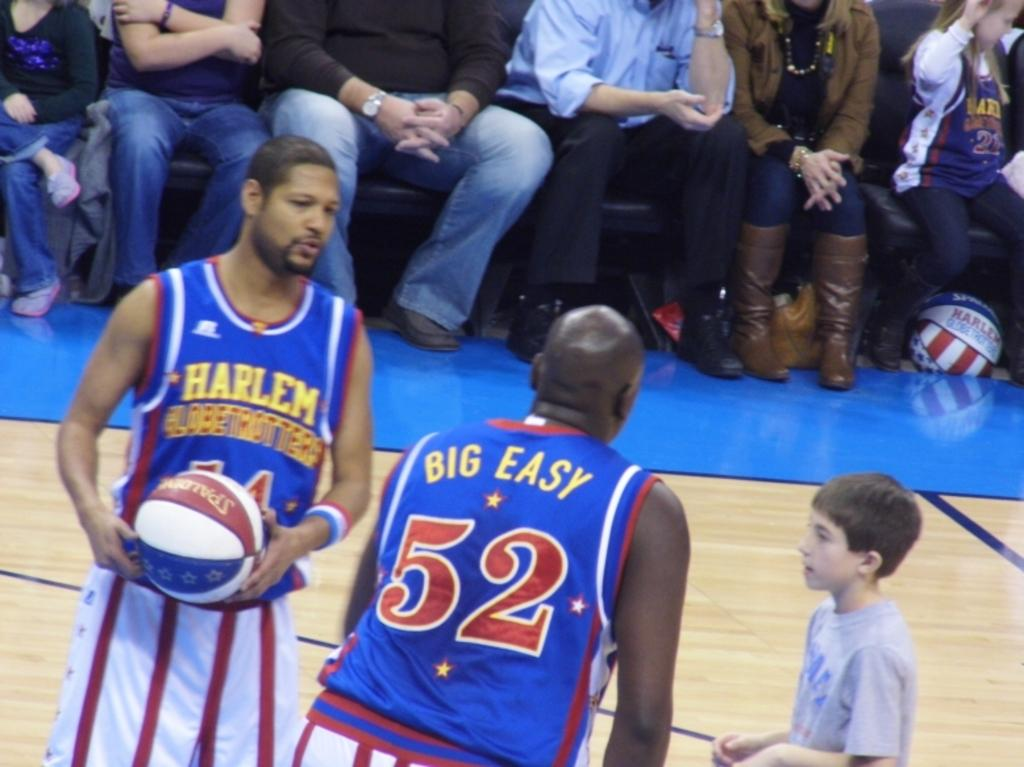Provide a one-sentence caption for the provided image. Basketball game with blue uniforms and Harlem Globetrotters on the front in yellow. 